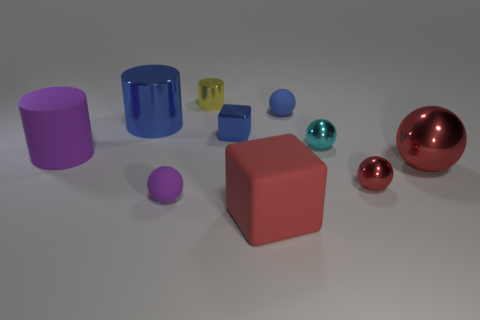What color is the small thing that is the same shape as the large purple rubber object?
Provide a succinct answer. Yellow. There is a block that is behind the purple matte cylinder; does it have the same size as the small red object?
Your response must be concise. Yes. Is the number of small rubber balls that are on the left side of the red rubber cube less than the number of large balls?
Provide a succinct answer. No. Is there any other thing that is the same size as the blue cylinder?
Your answer should be compact. Yes. There is a cylinder right of the blue cylinder that is in front of the small metal cylinder; how big is it?
Your answer should be very brief. Small. Are there any other things that are the same shape as the big purple object?
Provide a short and direct response. Yes. Is the number of brown matte balls less than the number of metallic things?
Make the answer very short. Yes. There is a large thing that is on the left side of the small yellow cylinder and in front of the blue cylinder; what material is it?
Your response must be concise. Rubber. Is there a tiny cube left of the tiny rubber thing that is in front of the large ball?
Ensure brevity in your answer.  No. What number of objects are big rubber cylinders or large cubes?
Make the answer very short. 2. 